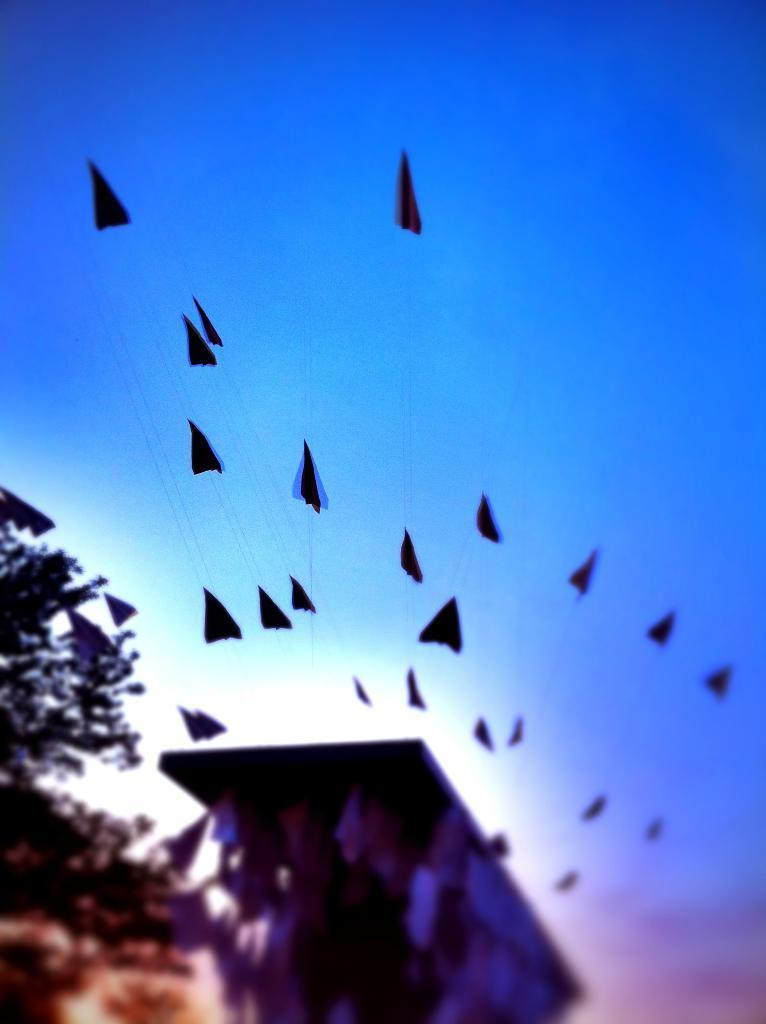What objects are in the image that are related to flying? There are paper kites in the image. What can be seen on the left side of the image? There is a tree on the left side of the image. What is the material of the object that appears to be used for covering or drying? There is a sheet in the image, which is typically made of fabric or paper. What color is the sky in the background of the image? The sky is blue in the background of the image. What type of amusement can be seen in the image? There is no amusement park or ride present in the image; it features paper kites and a tree. Can you recite a verse that is written on the sheet in the image? There is no verse or writing visible on the sheet in the image. 